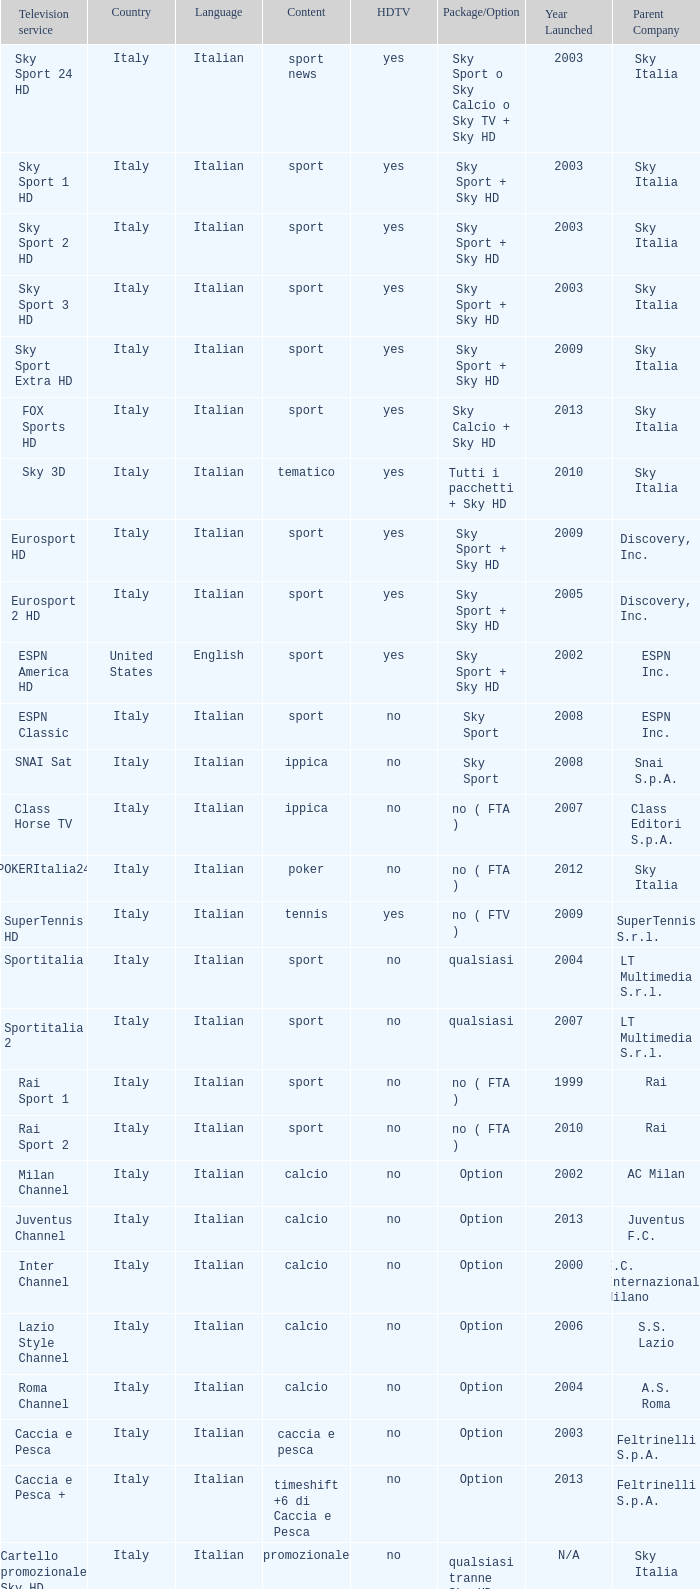What is television provider when the subject is calcio, and when the selection/possibility is option? Milan Channel, Juventus Channel, Inter Channel, Lazio Style Channel, Roma Channel. Could you help me parse every detail presented in this table? {'header': ['Television service', 'Country', 'Language', 'Content', 'HDTV', 'Package/Option', 'Year Launched', 'Parent Company'], 'rows': [['Sky Sport 24 HD', 'Italy', 'Italian', 'sport news', 'yes', 'Sky Sport o Sky Calcio o Sky TV + Sky HD', '2003', 'Sky Italia'], ['Sky Sport 1 HD', 'Italy', 'Italian', 'sport', 'yes', 'Sky Sport + Sky HD', '2003', 'Sky Italia'], ['Sky Sport 2 HD', 'Italy', 'Italian', 'sport', 'yes', 'Sky Sport + Sky HD', '2003', 'Sky Italia'], ['Sky Sport 3 HD', 'Italy', 'Italian', 'sport', 'yes', 'Sky Sport + Sky HD', '2003', 'Sky Italia'], ['Sky Sport Extra HD', 'Italy', 'Italian', 'sport', 'yes', 'Sky Sport + Sky HD', '2009', 'Sky Italia'], ['FOX Sports HD', 'Italy', 'Italian', 'sport', 'yes', 'Sky Calcio + Sky HD', '2013', 'Sky Italia'], ['Sky 3D', 'Italy', 'Italian', 'tematico', 'yes', 'Tutti i pacchetti + Sky HD', '2010', 'Sky Italia'], ['Eurosport HD', 'Italy', 'Italian', 'sport', 'yes', 'Sky Sport + Sky HD', '2009', 'Discovery, Inc.'], ['Eurosport 2 HD', 'Italy', 'Italian', 'sport', 'yes', 'Sky Sport + Sky HD', '2005', 'Discovery, Inc.'], ['ESPN America HD', 'United States', 'English', 'sport', 'yes', 'Sky Sport + Sky HD', '2002', 'ESPN Inc.'], ['ESPN Classic', 'Italy', 'Italian', 'sport', 'no', 'Sky Sport', '2008', 'ESPN Inc.'], ['SNAI Sat', 'Italy', 'Italian', 'ippica', 'no', 'Sky Sport', '2008', 'Snai S.p.A.'], ['Class Horse TV', 'Italy', 'Italian', 'ippica', 'no', 'no ( FTA )', '2007', 'Class Editori S.p.A.'], ['POKERItalia24', 'Italy', 'Italian', 'poker', 'no', 'no ( FTA )', '2012', 'Sky Italia'], ['SuperTennis HD', 'Italy', 'Italian', 'tennis', 'yes', 'no ( FTV )', '2009', 'SuperTennis S.r.l.'], ['Sportitalia', 'Italy', 'Italian', 'sport', 'no', 'qualsiasi', '2004', 'LT Multimedia S.r.l.'], ['Sportitalia 2', 'Italy', 'Italian', 'sport', 'no', 'qualsiasi', '2007', 'LT Multimedia S.r.l.'], ['Rai Sport 1', 'Italy', 'Italian', 'sport', 'no', 'no ( FTA )', '1999', 'Rai'], ['Rai Sport 2', 'Italy', 'Italian', 'sport', 'no', 'no ( FTA )', '2010', 'Rai'], ['Milan Channel', 'Italy', 'Italian', 'calcio', 'no', 'Option', '2002', 'AC Milan'], ['Juventus Channel', 'Italy', 'Italian', 'calcio', 'no', 'Option', '2013', 'Juventus F.C.'], ['Inter Channel', 'Italy', 'Italian', 'calcio', 'no', 'Option', '2000', 'F.C. Internazionale Milano'], ['Lazio Style Channel', 'Italy', 'Italian', 'calcio', 'no', 'Option', '2006', 'S.S. Lazio'], ['Roma Channel', 'Italy', 'Italian', 'calcio', 'no', 'Option', '2004', 'A.S. Roma'], ['Caccia e Pesca', 'Italy', 'Italian', 'caccia e pesca', 'no', 'Option', '2003', 'Feltrinelli S.p.A.'], ['Caccia e Pesca +', 'Italy', 'Italian', 'timeshift +6 di Caccia e Pesca', 'no', 'Option', '2013', 'Feltrinelli S.p.A.'], ['Cartello promozionale Sky HD', 'Italy', 'Italian', 'promozionale', 'no', 'qualsiasi tranne Sky HD', 'N/A', 'Sky Italia'], ['Sky Sport 1', 'Italy', 'Italian', 'sport', 'no', 'Sky Sport', '2003', 'Sky Italia'], ['Cartello promozionale Sky HD', 'Italy', 'Italian', 'promozionale', 'no', 'qualsiasi tranne Sky HD', 'N/A', 'Sky Italia'], ['Sky Sport 2', 'Italy', 'Italian', 'sport', 'no', 'Sky Sport', '2003', 'Sky Italia'], ['Cartello promozionale Sky HD', 'Italy', 'Italian', 'promozionale', 'no', 'qualsiasi tranne Sky HD', 'N/A', 'Sky Italia'], ['Sky Sport 3', 'Italy', 'Italian', 'sport', 'no', 'Sky Sport', '2003', 'Sky Italia'], ['Cartello promozionale Sky HD', 'Italy', 'Italian', 'promozionale', 'no', 'qualsiasi tranne Sky HD', 'N/A', 'Sky Italia'], ['Sky Sport Extra', 'Italy', 'Italian', 'sport', 'no', 'Sky Sport', '2009', 'Sky Italia'], ['Cartello promozionale Sky HD', 'Italy', 'Italian', 'promozionale', 'no', 'qualsiasi tranne Sky HD', 'N/A', 'Sky Italia'], ['Sky Supercalcio', 'Italy', 'Italian', 'calcio', 'no', 'Sky Calcio', '2003', 'Sky Italia'], ['Cartello promozionale Sky HD', 'Italy', 'Italian', 'promozionale', 'no', 'qualsiasi tranne Sky HD', 'N/A', 'Sky Italia'], ['Eurosport', 'Italy', 'Italian', 'sport', 'no', 'Sky Sport', '2009', 'Discovery, Inc.'], ['Eurosport 2', 'Italy', 'Italian', 'sport', 'no', 'Sky Sport', '2005', 'Discovery, Inc.'], ['ESPN America', 'Italy', 'Italian', 'sport', 'no', 'Sky Sport', '2002', 'ESPN Inc.']]} 